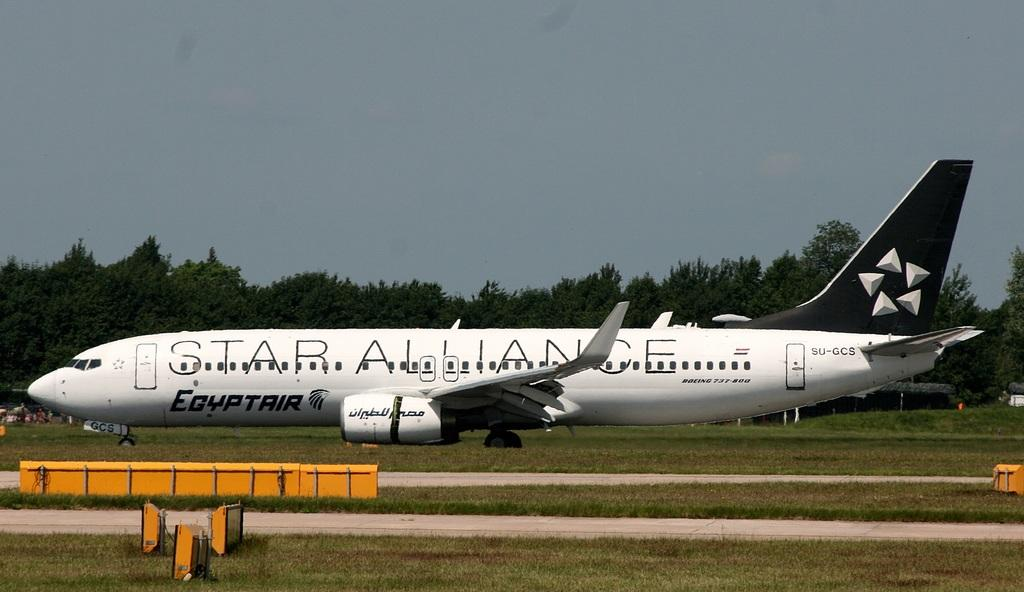<image>
Give a short and clear explanation of the subsequent image. The star Alliance plane sitting on the runway is from EgyptAir. 